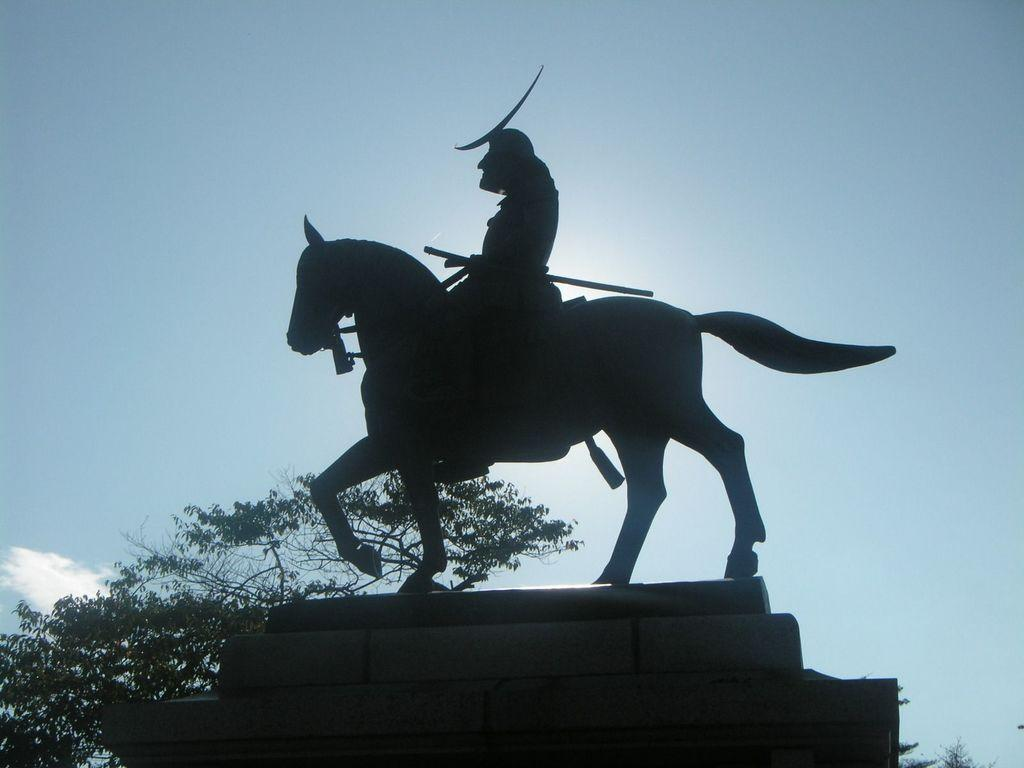What is the main subject of the image? There is a statue of a person in the image. How is the person depicted in the statue? The person is depicted as sitting on a horse. What can be seen in the background of the image? There are trees and the sky visible in the background of the image. What type of soda is being poured into the statue's hand in the image? There is no soda present in the image, and the statue's hand is not depicted as holding or receiving any liquid. 